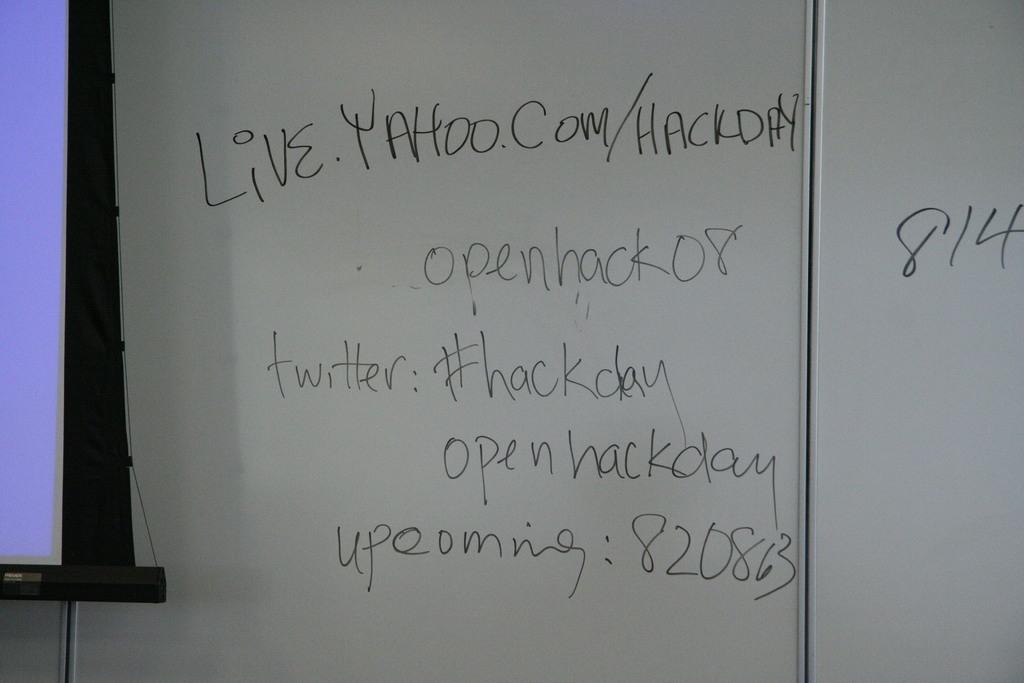What is the twitter handle?
Offer a terse response. #hackday. What website is displayed?
Your answer should be very brief. Live.yahoo.com/hackday. 